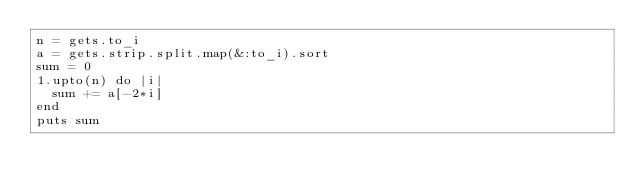<code> <loc_0><loc_0><loc_500><loc_500><_Ruby_>n = gets.to_i
a = gets.strip.split.map(&:to_i).sort
sum = 0
1.upto(n) do |i|
  sum += a[-2*i]
end
puts sum
</code> 